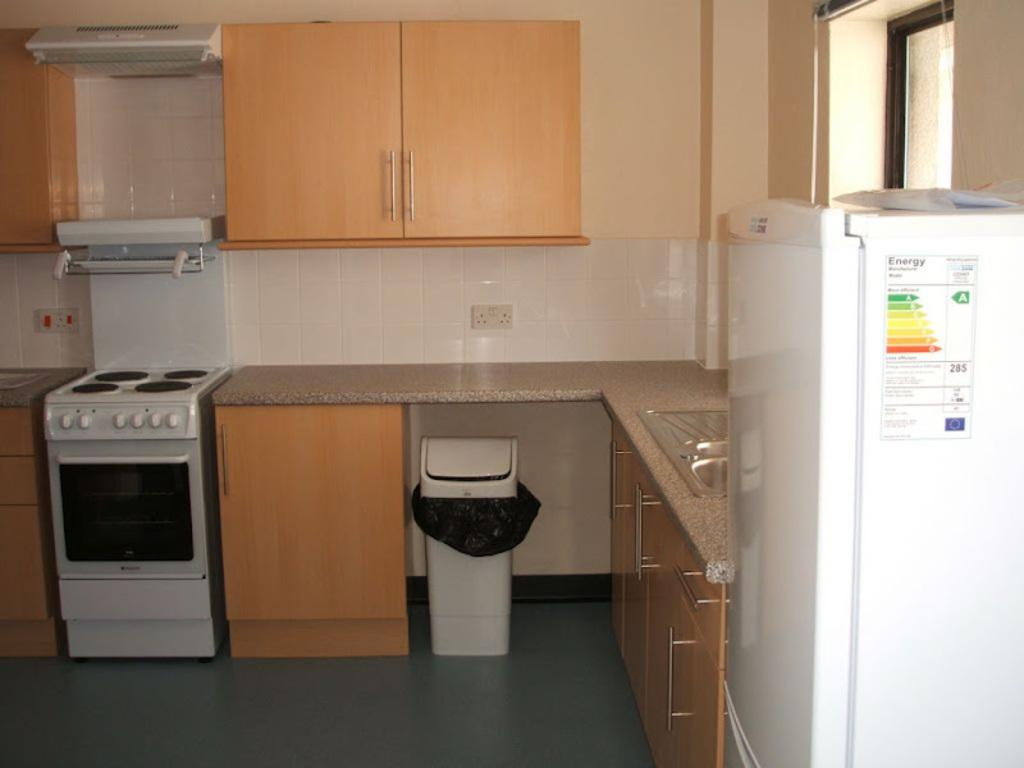<image>
Write a terse but informative summary of the picture. A clean kitchen with the Energy sticker still in place on the fridge 